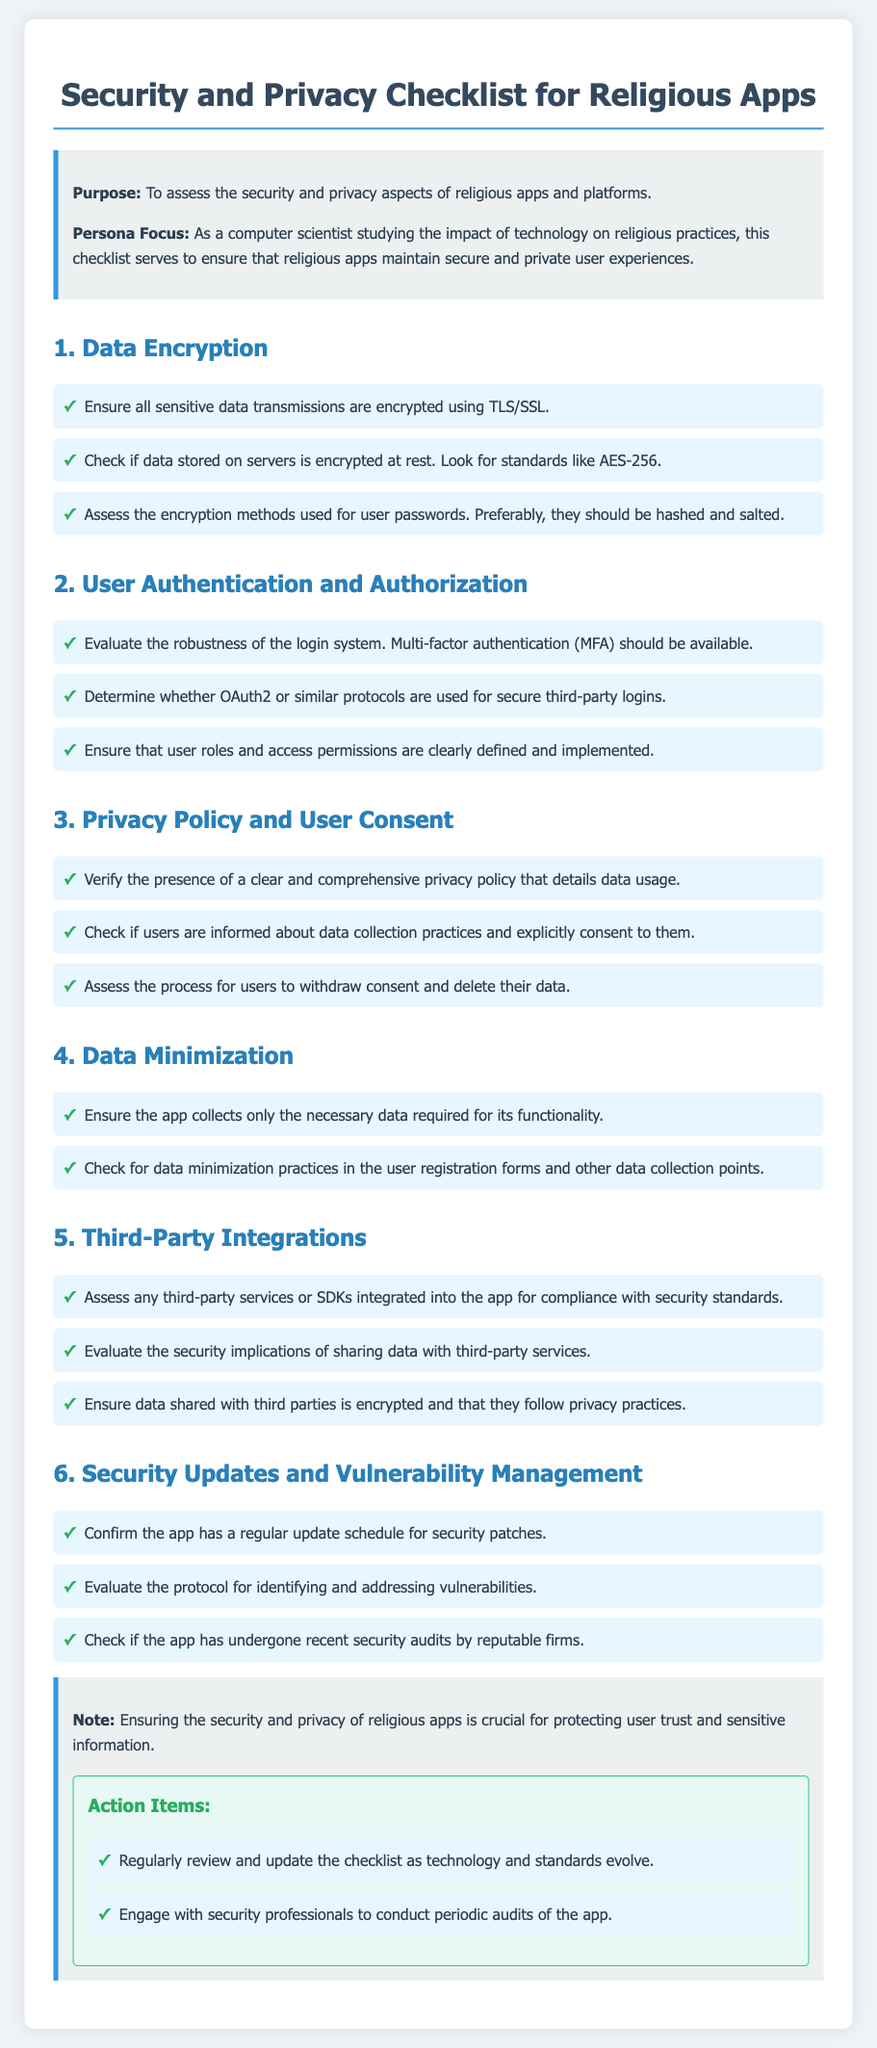What is the title of the document? The title is provided in the header section of the document.
Answer: Security and Privacy Checklist for Religious Apps How many key areas are listed in the checklist? The document lists six key areas that assess security and privacy.
Answer: Six What is the encryption standard recommended for data stored on servers? The checklist mentions that data stored on servers should be encrypted using standards such as AES-256.
Answer: AES-256 What user authentication method is suggested for stronger security? The checklist recommends multi-factor authentication (MFA) for user login systems.
Answer: Multi-factor authentication Which section addresses user consent regarding data collection? The section titled "Privacy Policy and User Consent" specifically discusses user consent and data collection practices.
Answer: Privacy Policy and User Consent What should users be able to do regarding their consent? The checklist emphasizes that users should have a process to withdraw consent and delete their data.
Answer: Withdraw consent and delete their data Which entity does the document suggest should conduct periodic audits of the app? The document highlights the importance of engaging with security professionals for audits.
Answer: Security professionals Which area discusses the handling of third-party services? The section titled "Third-Party Integrations" deals with the assessment of third-party services in the app.
Answer: Third-Party Integrations What is one of the action items listed for maintaining security? The action items suggest regularly reviewing and updating the checklist as technology and standards evolve.
Answer: Review and update the checklist 